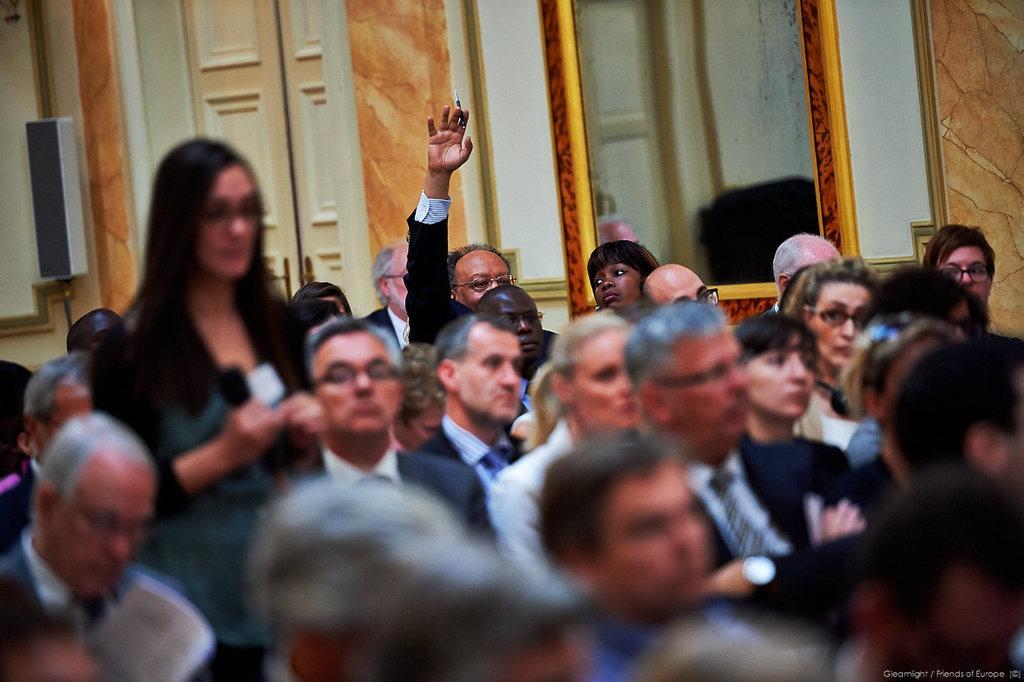Please provide a concise description of this image. In this image we can see people sitting. We can also see a man raising his hand. There is a woman standing and holding the mike. In the background there is door, a mirror attached to the wall and also a sound box. 